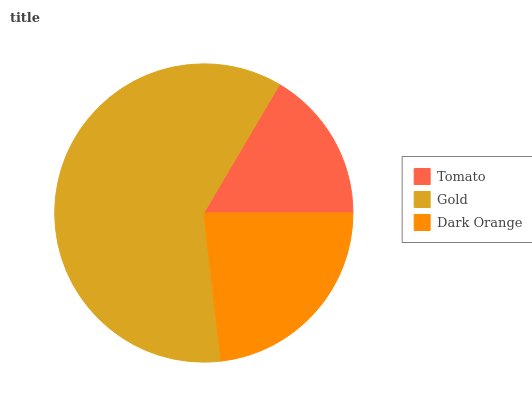Is Tomato the minimum?
Answer yes or no. Yes. Is Gold the maximum?
Answer yes or no. Yes. Is Dark Orange the minimum?
Answer yes or no. No. Is Dark Orange the maximum?
Answer yes or no. No. Is Gold greater than Dark Orange?
Answer yes or no. Yes. Is Dark Orange less than Gold?
Answer yes or no. Yes. Is Dark Orange greater than Gold?
Answer yes or no. No. Is Gold less than Dark Orange?
Answer yes or no. No. Is Dark Orange the high median?
Answer yes or no. Yes. Is Dark Orange the low median?
Answer yes or no. Yes. Is Gold the high median?
Answer yes or no. No. Is Gold the low median?
Answer yes or no. No. 